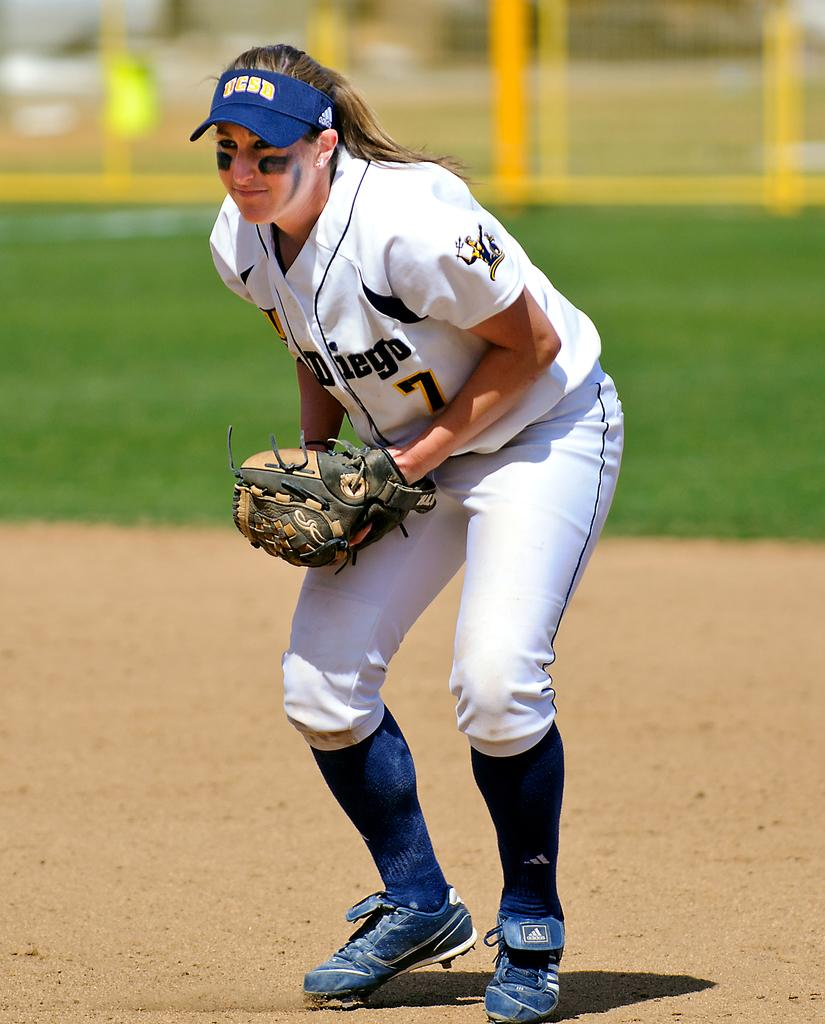<image>
Share a concise interpretation of the image provided. a woman in a UCSD visor and uniform is ready to catch a baseball 